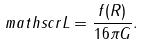Convert formula to latex. <formula><loc_0><loc_0><loc_500><loc_500>\ m a t h s c r L = \frac { f ( R ) } { 1 6 \pi G } .</formula> 